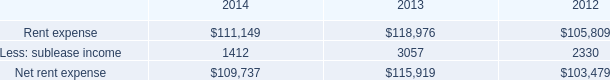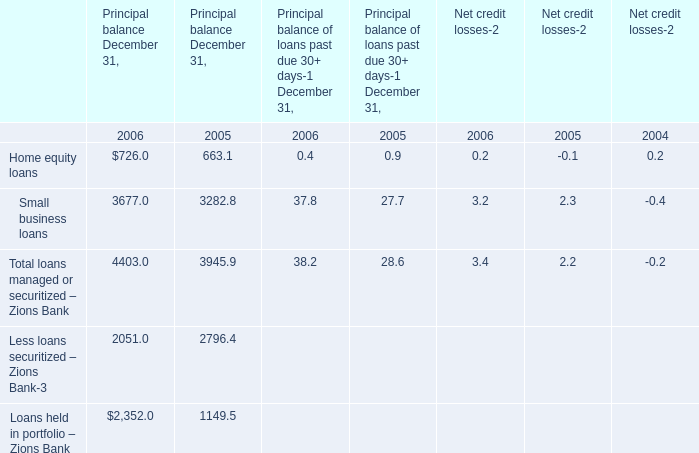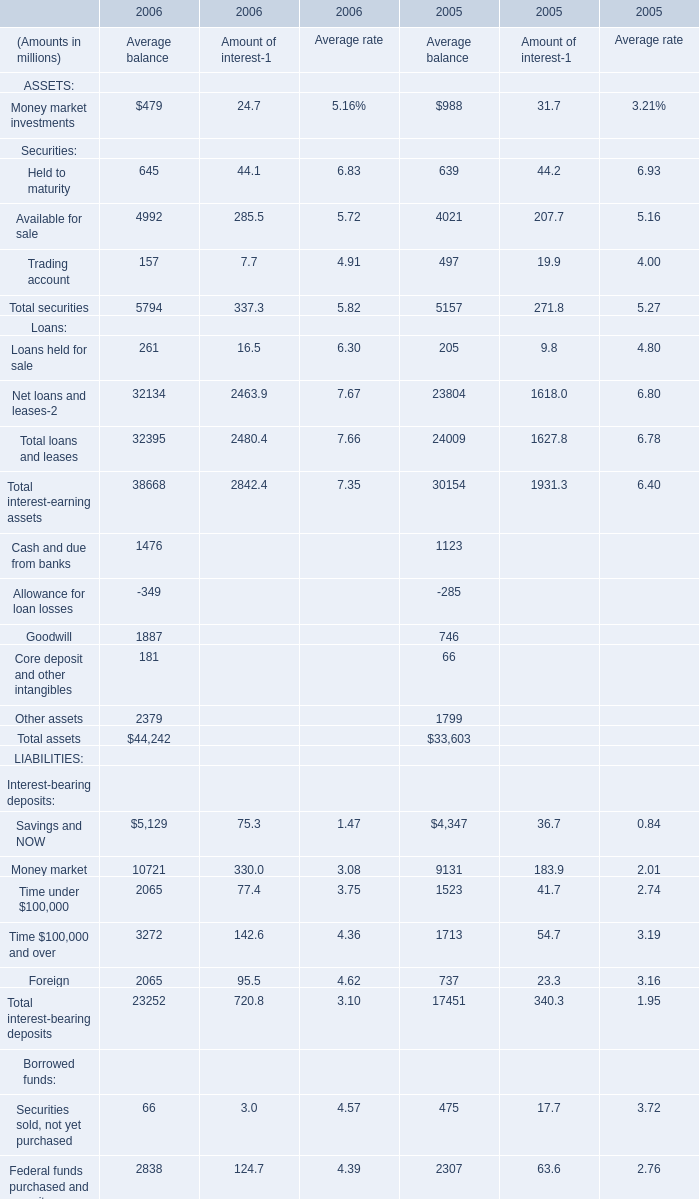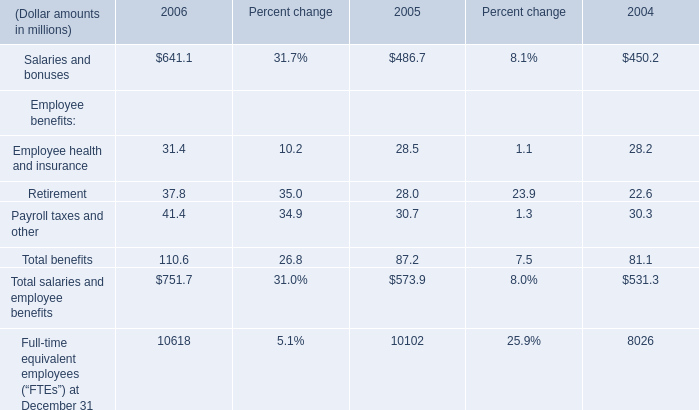What's the total amount of the Home equity loans for Principal balance December 31, in the years where Retirement for Employee benefits than 25? 
Computations: (726.0 + 663.1)
Answer: 1389.1. 